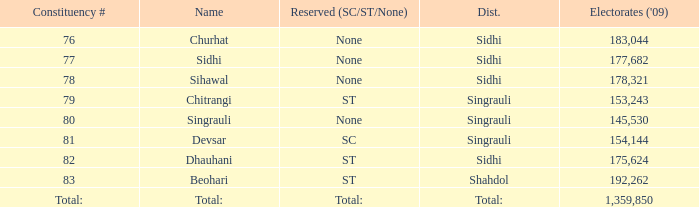Could you help me parse every detail presented in this table? {'header': ['Constituency #', 'Name', 'Reserved (SC/ST/None)', 'Dist.', "Electorates ('09)"], 'rows': [['76', 'Churhat', 'None', 'Sidhi', '183,044'], ['77', 'Sidhi', 'None', 'Sidhi', '177,682'], ['78', 'Sihawal', 'None', 'Sidhi', '178,321'], ['79', 'Chitrangi', 'ST', 'Singrauli', '153,243'], ['80', 'Singrauli', 'None', 'Singrauli', '145,530'], ['81', 'Devsar', 'SC', 'Singrauli', '154,144'], ['82', 'Dhauhani', 'ST', 'Sidhi', '175,624'], ['83', 'Beohari', 'ST', 'Shahdol', '192,262'], ['Total:', 'Total:', 'Total:', 'Total:', '1,359,850']]} What is Beohari's reserved for (SC/ST/None)? ST. 